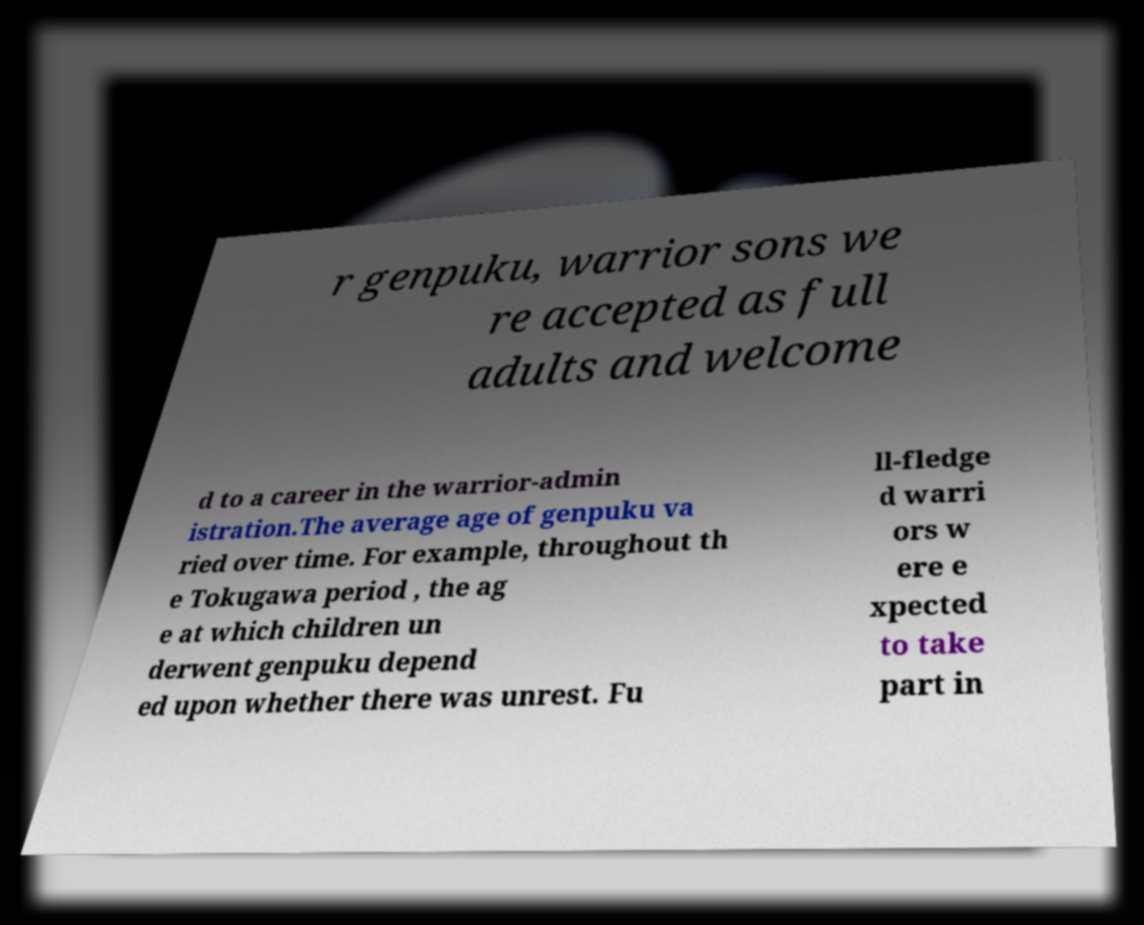Can you read and provide the text displayed in the image?This photo seems to have some interesting text. Can you extract and type it out for me? r genpuku, warrior sons we re accepted as full adults and welcome d to a career in the warrior-admin istration.The average age of genpuku va ried over time. For example, throughout th e Tokugawa period , the ag e at which children un derwent genpuku depend ed upon whether there was unrest. Fu ll-fledge d warri ors w ere e xpected to take part in 